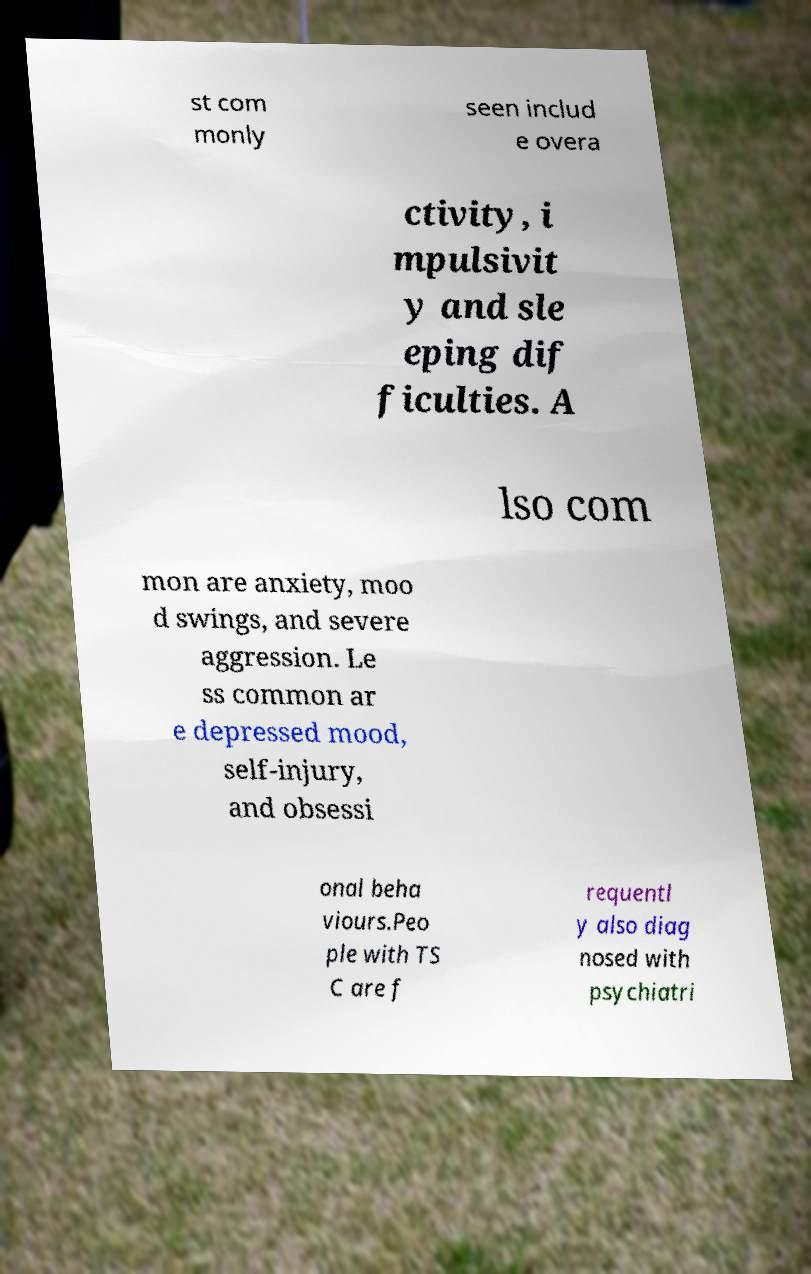There's text embedded in this image that I need extracted. Can you transcribe it verbatim? st com monly seen includ e overa ctivity, i mpulsivit y and sle eping dif ficulties. A lso com mon are anxiety, moo d swings, and severe aggression. Le ss common ar e depressed mood, self-injury, and obsessi onal beha viours.Peo ple with TS C are f requentl y also diag nosed with psychiatri 